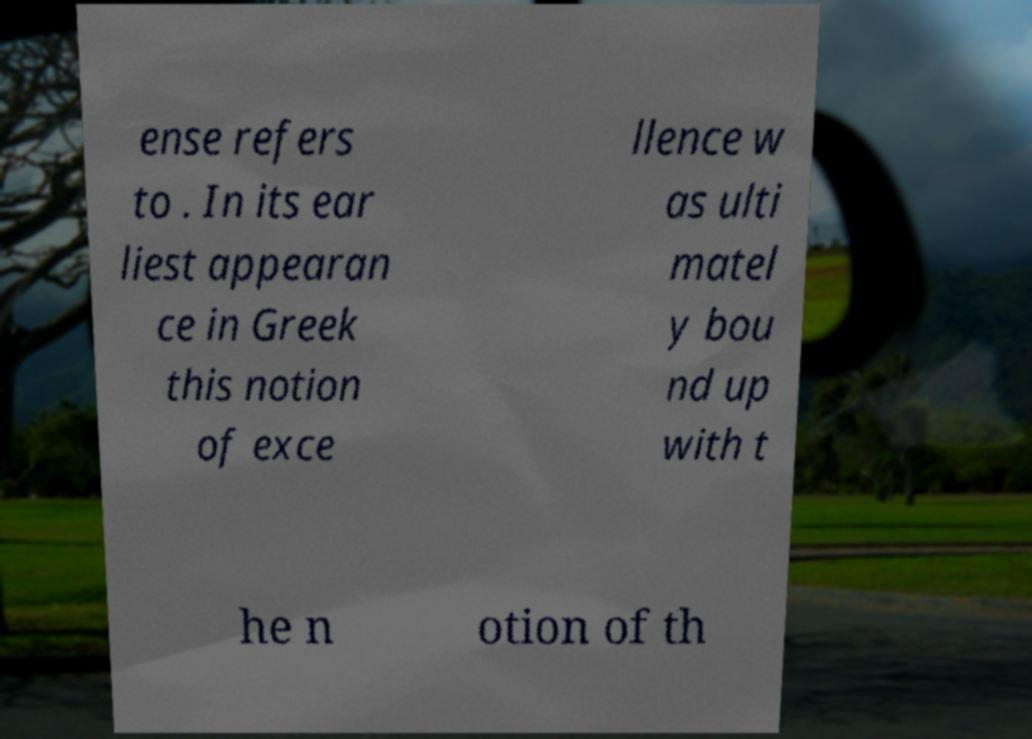Could you assist in decoding the text presented in this image and type it out clearly? ense refers to . In its ear liest appearan ce in Greek this notion of exce llence w as ulti matel y bou nd up with t he n otion of th 